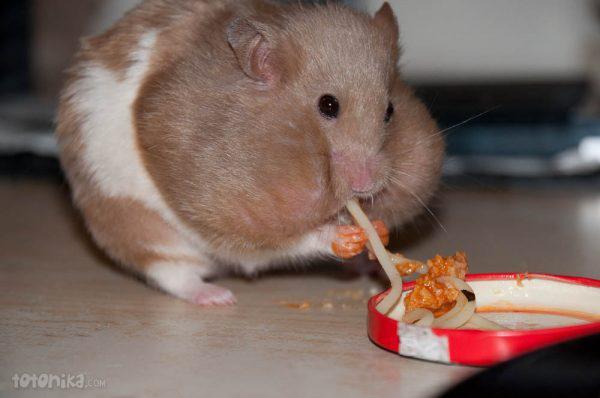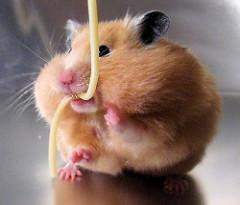The first image is the image on the left, the second image is the image on the right. Considering the images on both sides, is "The rodent is sitting in its food in one of the images." valid? Answer yes or no. No. The first image is the image on the left, the second image is the image on the right. For the images displayed, is the sentence "An image shows a pet rodent holding an orange food item in both front paws." factually correct? Answer yes or no. No. 